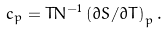Convert formula to latex. <formula><loc_0><loc_0><loc_500><loc_500>c _ { p } = T N ^ { - 1 } \left ( { \partial S } / { \partial T } \right ) _ { p } .</formula> 